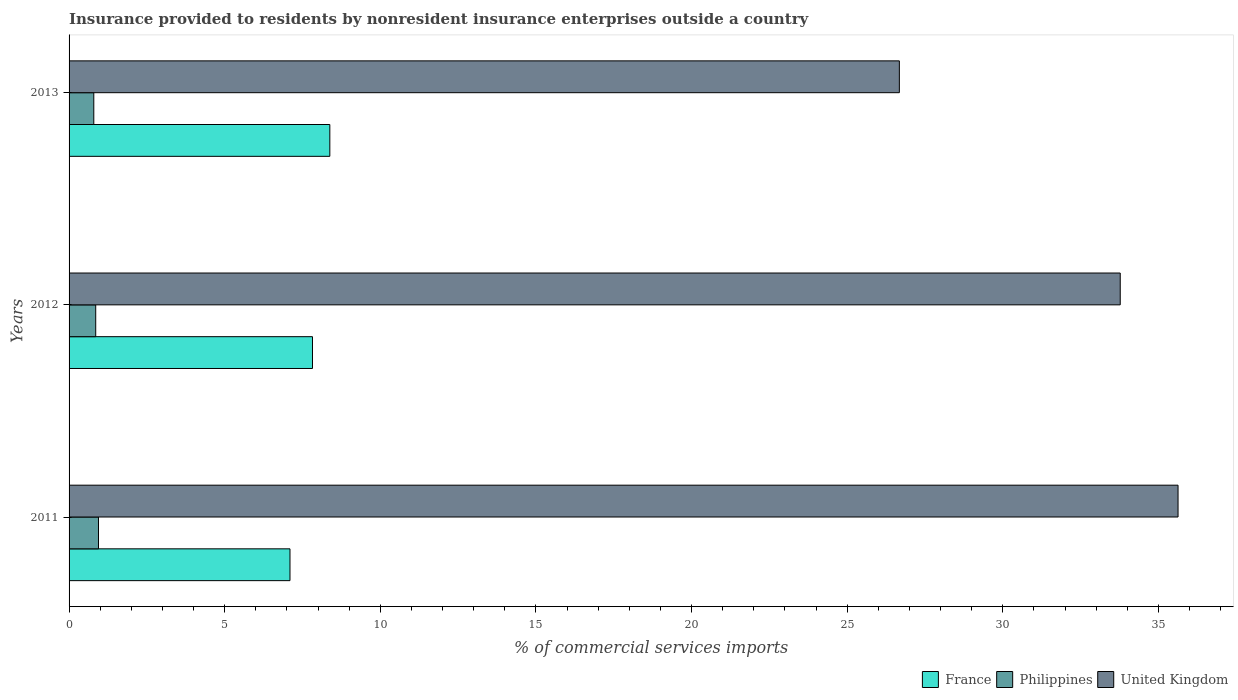How many bars are there on the 3rd tick from the top?
Ensure brevity in your answer.  3. What is the label of the 2nd group of bars from the top?
Provide a succinct answer. 2012. What is the Insurance provided to residents in Philippines in 2013?
Offer a very short reply. 0.79. Across all years, what is the maximum Insurance provided to residents in Philippines?
Keep it short and to the point. 0.95. Across all years, what is the minimum Insurance provided to residents in France?
Your answer should be very brief. 7.1. In which year was the Insurance provided to residents in United Kingdom maximum?
Offer a terse response. 2011. What is the total Insurance provided to residents in Philippines in the graph?
Offer a terse response. 2.6. What is the difference between the Insurance provided to residents in Philippines in 2012 and that in 2013?
Ensure brevity in your answer.  0.06. What is the difference between the Insurance provided to residents in United Kingdom in 2011 and the Insurance provided to residents in France in 2012?
Offer a very short reply. 27.81. What is the average Insurance provided to residents in United Kingdom per year?
Offer a very short reply. 32.03. In the year 2012, what is the difference between the Insurance provided to residents in France and Insurance provided to residents in United Kingdom?
Provide a short and direct response. -25.95. In how many years, is the Insurance provided to residents in United Kingdom greater than 14 %?
Your response must be concise. 3. What is the ratio of the Insurance provided to residents in France in 2011 to that in 2013?
Provide a succinct answer. 0.85. Is the Insurance provided to residents in France in 2012 less than that in 2013?
Make the answer very short. Yes. Is the difference between the Insurance provided to residents in France in 2011 and 2013 greater than the difference between the Insurance provided to residents in United Kingdom in 2011 and 2013?
Your response must be concise. No. What is the difference between the highest and the second highest Insurance provided to residents in France?
Ensure brevity in your answer.  0.56. What is the difference between the highest and the lowest Insurance provided to residents in United Kingdom?
Make the answer very short. 8.95. Is the sum of the Insurance provided to residents in United Kingdom in 2011 and 2013 greater than the maximum Insurance provided to residents in Philippines across all years?
Your response must be concise. Yes. What does the 1st bar from the top in 2013 represents?
Your answer should be compact. United Kingdom. What does the 2nd bar from the bottom in 2012 represents?
Your response must be concise. Philippines. How many bars are there?
Provide a short and direct response. 9. Are all the bars in the graph horizontal?
Provide a short and direct response. Yes. How many years are there in the graph?
Give a very brief answer. 3. What is the difference between two consecutive major ticks on the X-axis?
Your answer should be compact. 5. Are the values on the major ticks of X-axis written in scientific E-notation?
Offer a terse response. No. Does the graph contain any zero values?
Offer a very short reply. No. Does the graph contain grids?
Your answer should be very brief. No. How are the legend labels stacked?
Give a very brief answer. Horizontal. What is the title of the graph?
Keep it short and to the point. Insurance provided to residents by nonresident insurance enterprises outside a country. What is the label or title of the X-axis?
Make the answer very short. % of commercial services imports. What is the label or title of the Y-axis?
Your response must be concise. Years. What is the % of commercial services imports in France in 2011?
Offer a very short reply. 7.1. What is the % of commercial services imports of Philippines in 2011?
Keep it short and to the point. 0.95. What is the % of commercial services imports of United Kingdom in 2011?
Make the answer very short. 35.63. What is the % of commercial services imports of France in 2012?
Make the answer very short. 7.82. What is the % of commercial services imports of Philippines in 2012?
Your answer should be compact. 0.86. What is the % of commercial services imports in United Kingdom in 2012?
Ensure brevity in your answer.  33.77. What is the % of commercial services imports of France in 2013?
Provide a succinct answer. 8.38. What is the % of commercial services imports in Philippines in 2013?
Ensure brevity in your answer.  0.79. What is the % of commercial services imports of United Kingdom in 2013?
Your answer should be very brief. 26.68. Across all years, what is the maximum % of commercial services imports in France?
Give a very brief answer. 8.38. Across all years, what is the maximum % of commercial services imports of Philippines?
Ensure brevity in your answer.  0.95. Across all years, what is the maximum % of commercial services imports of United Kingdom?
Keep it short and to the point. 35.63. Across all years, what is the minimum % of commercial services imports of France?
Provide a short and direct response. 7.1. Across all years, what is the minimum % of commercial services imports in Philippines?
Provide a short and direct response. 0.79. Across all years, what is the minimum % of commercial services imports in United Kingdom?
Provide a succinct answer. 26.68. What is the total % of commercial services imports of France in the graph?
Your answer should be very brief. 23.3. What is the total % of commercial services imports of Philippines in the graph?
Provide a short and direct response. 2.6. What is the total % of commercial services imports in United Kingdom in the graph?
Provide a short and direct response. 96.09. What is the difference between the % of commercial services imports of France in 2011 and that in 2012?
Give a very brief answer. -0.72. What is the difference between the % of commercial services imports of Philippines in 2011 and that in 2012?
Your answer should be compact. 0.09. What is the difference between the % of commercial services imports in United Kingdom in 2011 and that in 2012?
Offer a terse response. 1.86. What is the difference between the % of commercial services imports in France in 2011 and that in 2013?
Your response must be concise. -1.28. What is the difference between the % of commercial services imports in Philippines in 2011 and that in 2013?
Ensure brevity in your answer.  0.15. What is the difference between the % of commercial services imports in United Kingdom in 2011 and that in 2013?
Your answer should be compact. 8.95. What is the difference between the % of commercial services imports of France in 2012 and that in 2013?
Your response must be concise. -0.56. What is the difference between the % of commercial services imports of Philippines in 2012 and that in 2013?
Offer a very short reply. 0.06. What is the difference between the % of commercial services imports of United Kingdom in 2012 and that in 2013?
Provide a succinct answer. 7.1. What is the difference between the % of commercial services imports in France in 2011 and the % of commercial services imports in Philippines in 2012?
Ensure brevity in your answer.  6.24. What is the difference between the % of commercial services imports in France in 2011 and the % of commercial services imports in United Kingdom in 2012?
Ensure brevity in your answer.  -26.68. What is the difference between the % of commercial services imports in Philippines in 2011 and the % of commercial services imports in United Kingdom in 2012?
Provide a short and direct response. -32.83. What is the difference between the % of commercial services imports of France in 2011 and the % of commercial services imports of Philippines in 2013?
Keep it short and to the point. 6.3. What is the difference between the % of commercial services imports of France in 2011 and the % of commercial services imports of United Kingdom in 2013?
Give a very brief answer. -19.58. What is the difference between the % of commercial services imports in Philippines in 2011 and the % of commercial services imports in United Kingdom in 2013?
Provide a succinct answer. -25.73. What is the difference between the % of commercial services imports of France in 2012 and the % of commercial services imports of Philippines in 2013?
Offer a very short reply. 7.03. What is the difference between the % of commercial services imports in France in 2012 and the % of commercial services imports in United Kingdom in 2013?
Your answer should be compact. -18.86. What is the difference between the % of commercial services imports of Philippines in 2012 and the % of commercial services imports of United Kingdom in 2013?
Offer a very short reply. -25.82. What is the average % of commercial services imports of France per year?
Provide a succinct answer. 7.77. What is the average % of commercial services imports of Philippines per year?
Provide a succinct answer. 0.87. What is the average % of commercial services imports of United Kingdom per year?
Offer a very short reply. 32.03. In the year 2011, what is the difference between the % of commercial services imports of France and % of commercial services imports of Philippines?
Offer a very short reply. 6.15. In the year 2011, what is the difference between the % of commercial services imports of France and % of commercial services imports of United Kingdom?
Offer a terse response. -28.53. In the year 2011, what is the difference between the % of commercial services imports in Philippines and % of commercial services imports in United Kingdom?
Keep it short and to the point. -34.69. In the year 2012, what is the difference between the % of commercial services imports in France and % of commercial services imports in Philippines?
Your answer should be very brief. 6.96. In the year 2012, what is the difference between the % of commercial services imports of France and % of commercial services imports of United Kingdom?
Provide a succinct answer. -25.95. In the year 2012, what is the difference between the % of commercial services imports in Philippines and % of commercial services imports in United Kingdom?
Offer a terse response. -32.92. In the year 2013, what is the difference between the % of commercial services imports of France and % of commercial services imports of Philippines?
Keep it short and to the point. 7.58. In the year 2013, what is the difference between the % of commercial services imports of France and % of commercial services imports of United Kingdom?
Offer a terse response. -18.3. In the year 2013, what is the difference between the % of commercial services imports in Philippines and % of commercial services imports in United Kingdom?
Provide a short and direct response. -25.88. What is the ratio of the % of commercial services imports in France in 2011 to that in 2012?
Ensure brevity in your answer.  0.91. What is the ratio of the % of commercial services imports of Philippines in 2011 to that in 2012?
Your response must be concise. 1.1. What is the ratio of the % of commercial services imports in United Kingdom in 2011 to that in 2012?
Provide a succinct answer. 1.05. What is the ratio of the % of commercial services imports in France in 2011 to that in 2013?
Provide a succinct answer. 0.85. What is the ratio of the % of commercial services imports of Philippines in 2011 to that in 2013?
Your response must be concise. 1.19. What is the ratio of the % of commercial services imports in United Kingdom in 2011 to that in 2013?
Your response must be concise. 1.34. What is the ratio of the % of commercial services imports in France in 2012 to that in 2013?
Offer a very short reply. 0.93. What is the ratio of the % of commercial services imports of Philippines in 2012 to that in 2013?
Ensure brevity in your answer.  1.08. What is the ratio of the % of commercial services imports of United Kingdom in 2012 to that in 2013?
Provide a succinct answer. 1.27. What is the difference between the highest and the second highest % of commercial services imports in France?
Offer a very short reply. 0.56. What is the difference between the highest and the second highest % of commercial services imports of Philippines?
Offer a terse response. 0.09. What is the difference between the highest and the second highest % of commercial services imports in United Kingdom?
Keep it short and to the point. 1.86. What is the difference between the highest and the lowest % of commercial services imports of France?
Provide a short and direct response. 1.28. What is the difference between the highest and the lowest % of commercial services imports of Philippines?
Your answer should be very brief. 0.15. What is the difference between the highest and the lowest % of commercial services imports in United Kingdom?
Ensure brevity in your answer.  8.95. 